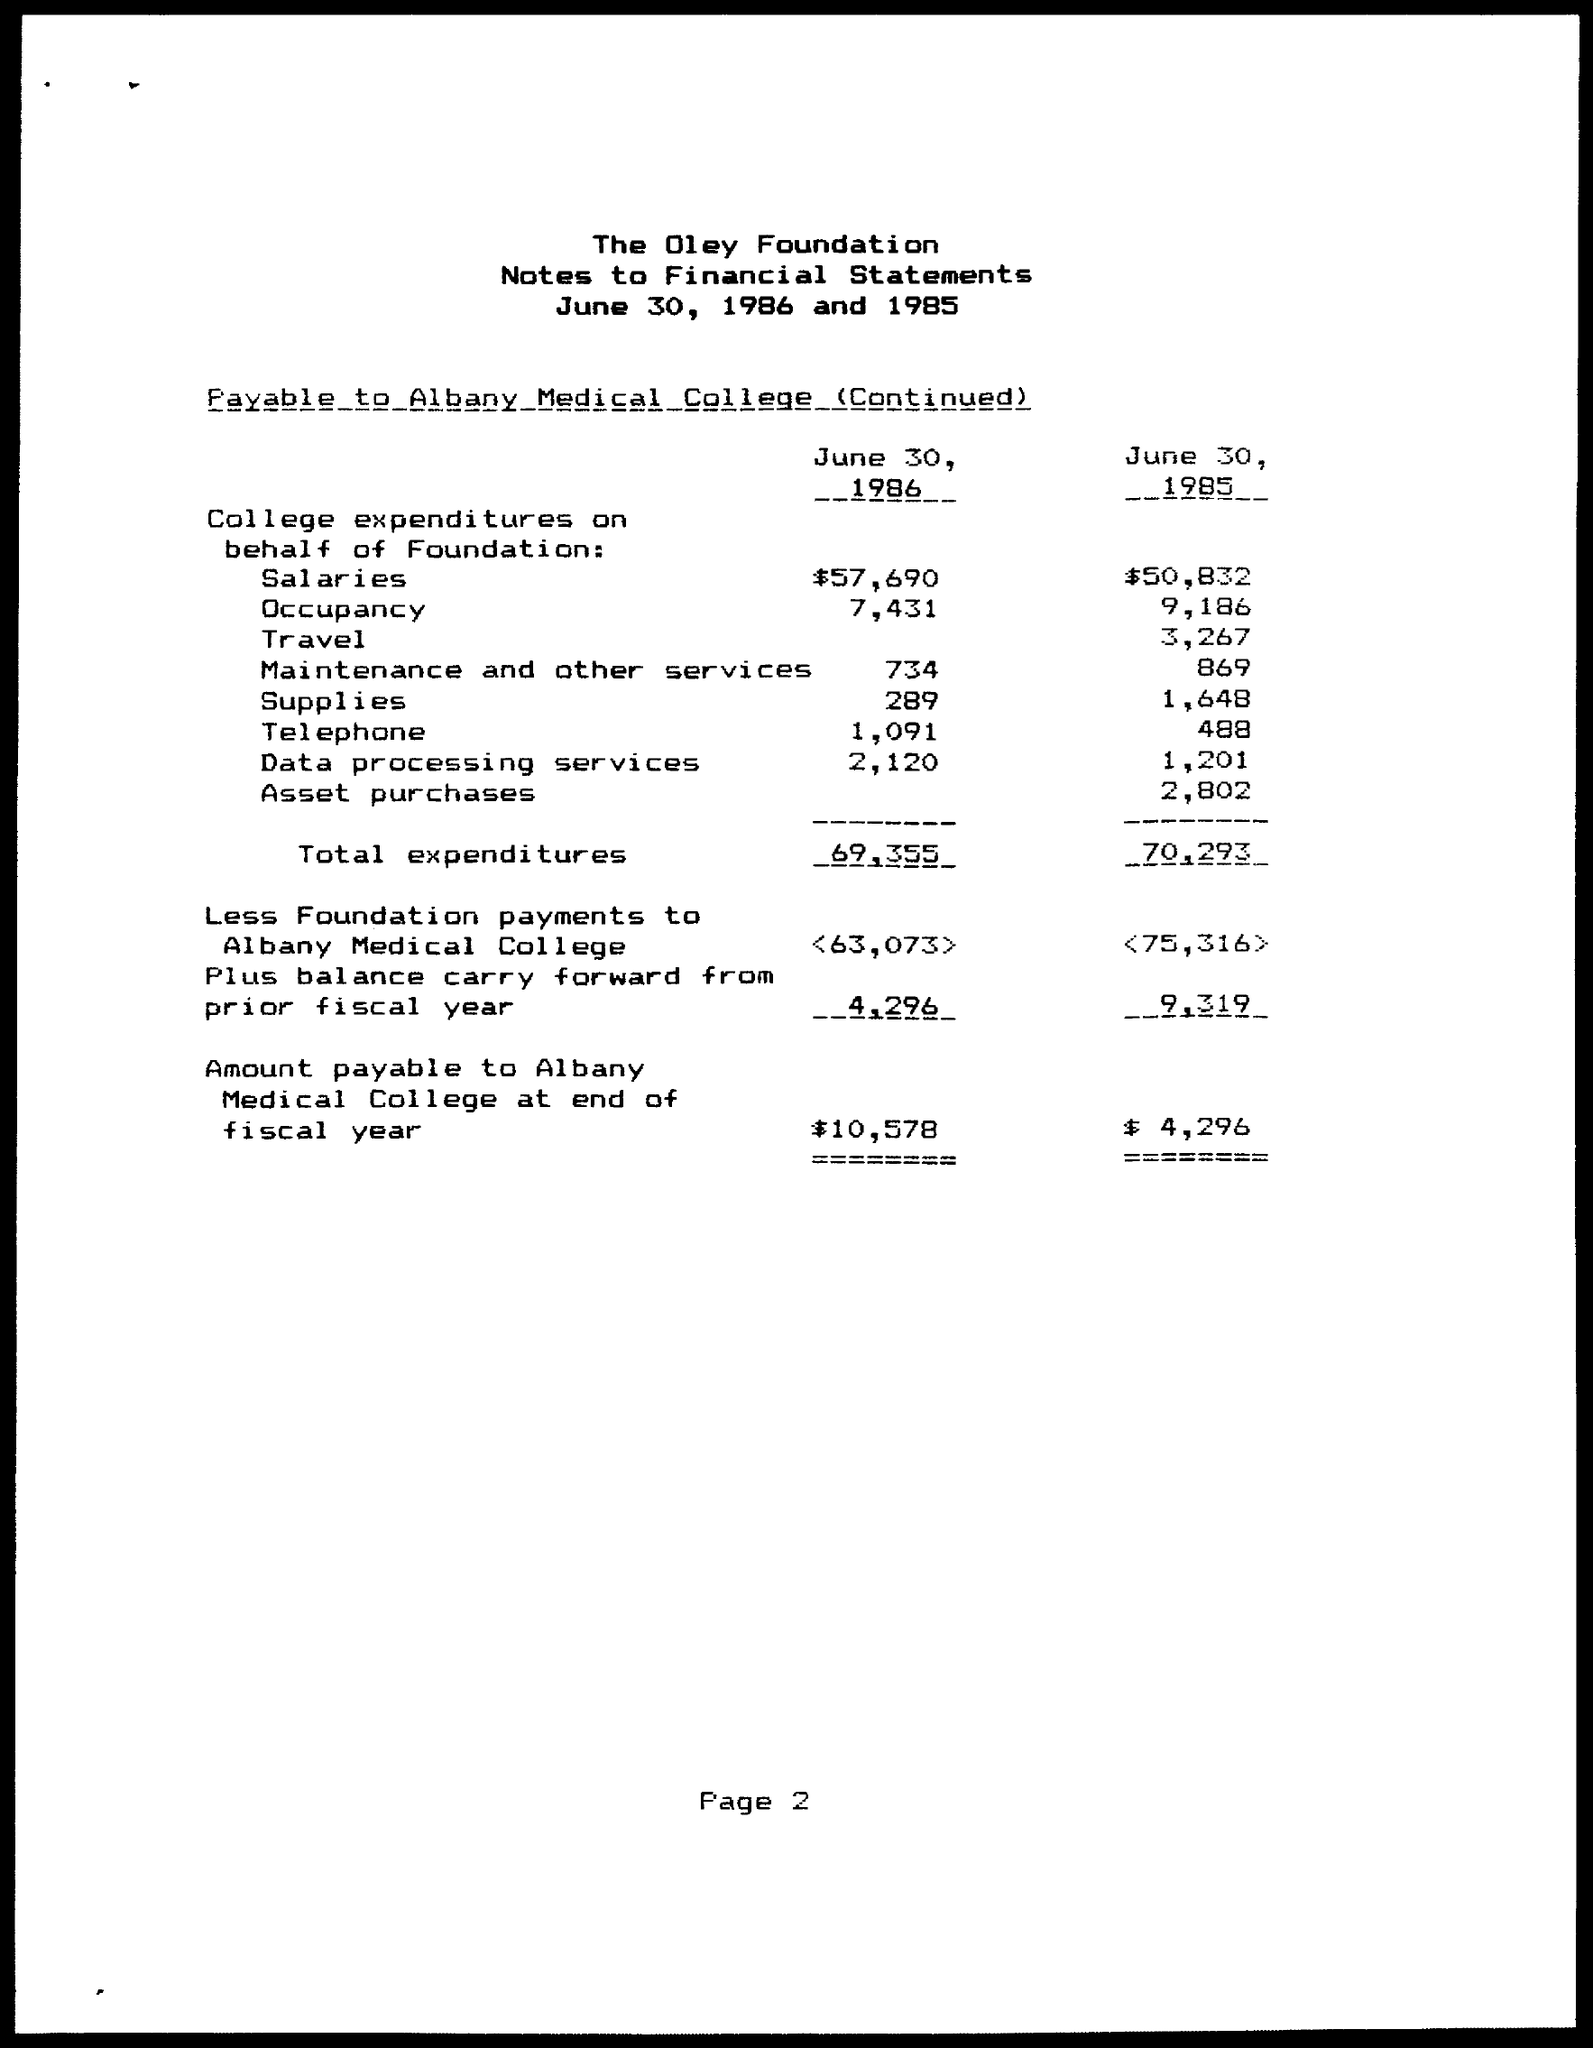Mention a couple of crucial points in this snapshot. The college's expenditures for supplies on behalf of the Foundation on June 30, 1985, were $1,648. The college's expenditures on behalf of the Foundation for travel on June 30, 1985, were $3,267. The expenditures on behalf of the Foundation by the College on June 30, 1985, were $9,186. On June 30, 1986, the college expended $57,690 on behalf of the foundation for salaries. The college's expenditures on behalf of the Foundation for supplies on June 30, 1986, were $289. 